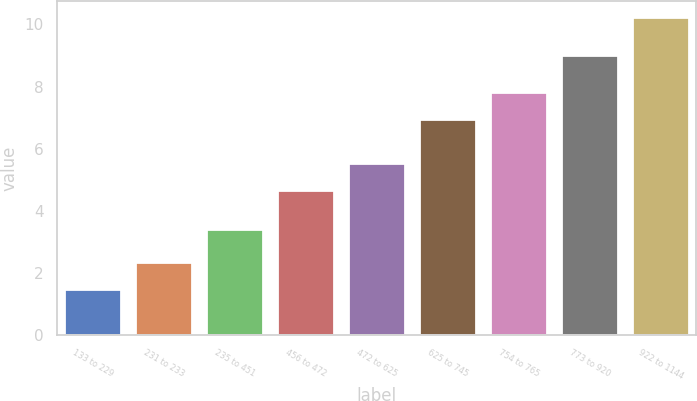Convert chart to OTSL. <chart><loc_0><loc_0><loc_500><loc_500><bar_chart><fcel>133 to 229<fcel>231 to 233<fcel>235 to 451<fcel>456 to 472<fcel>472 to 625<fcel>625 to 745<fcel>754 to 765<fcel>773 to 920<fcel>922 to 1144<nl><fcel>1.48<fcel>2.35<fcel>3.42<fcel>4.68<fcel>5.55<fcel>6.96<fcel>7.83<fcel>9.02<fcel>10.23<nl></chart> 